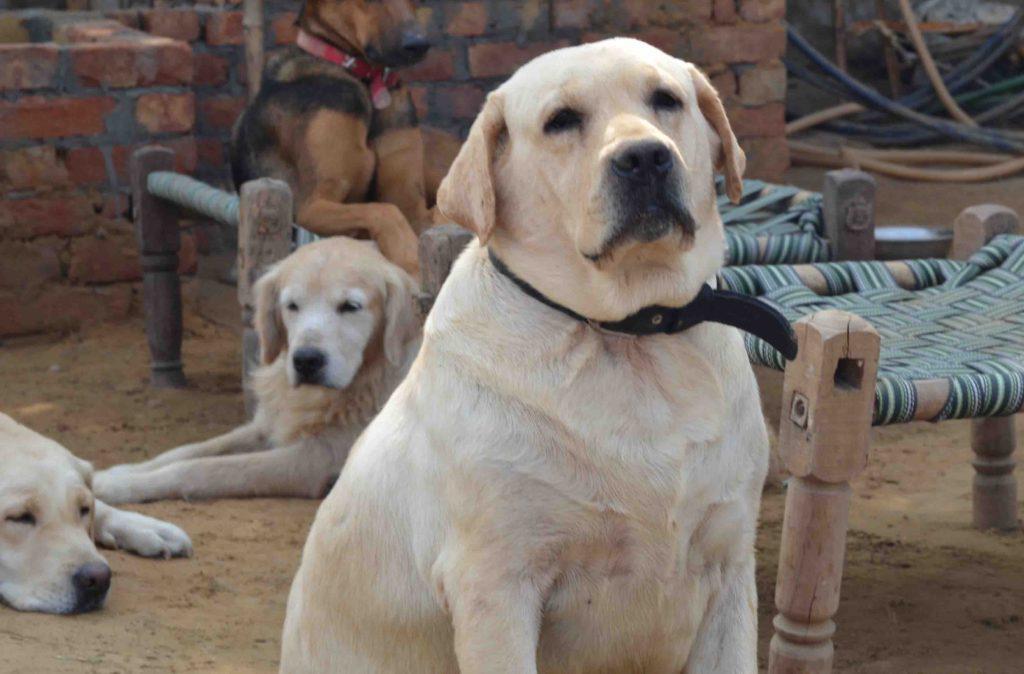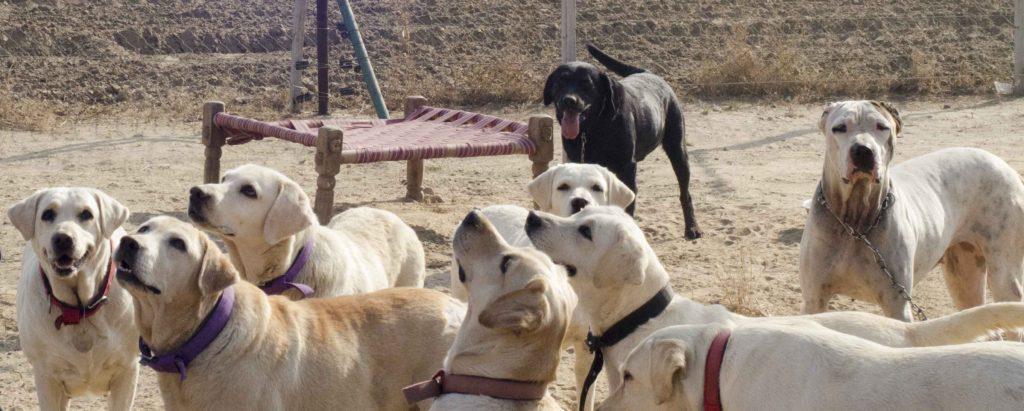The first image is the image on the left, the second image is the image on the right. For the images displayed, is the sentence "The right image contains one or more black labs." factually correct? Answer yes or no. Yes. 